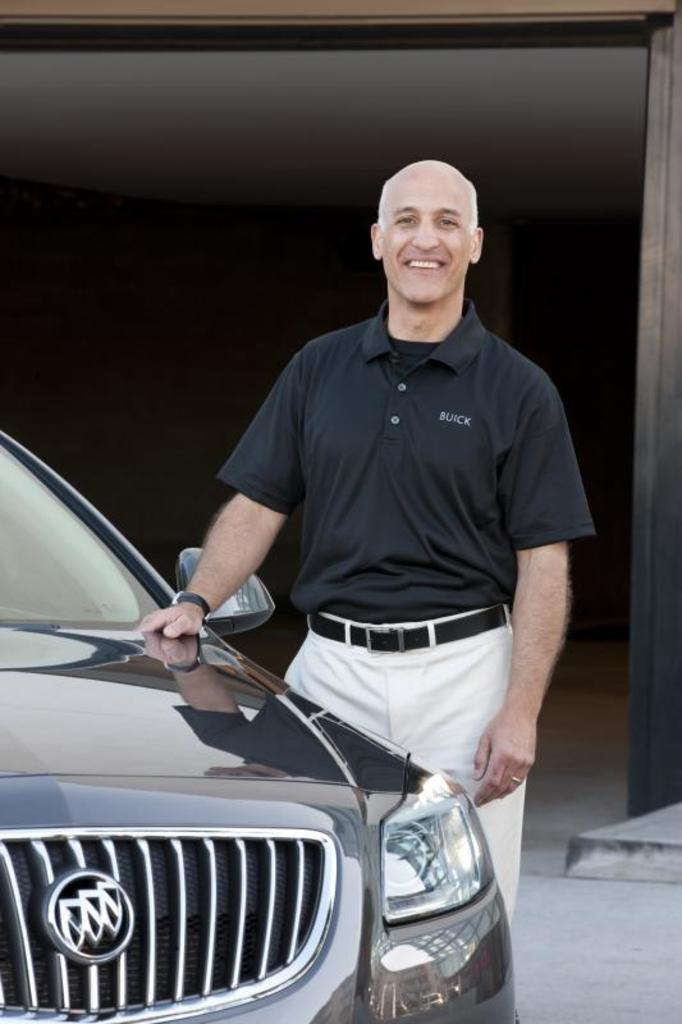What is the main subject of the image? There is a man standing in the middle of the image. What is the man wearing in the image? The man is wearing a black t-shirt. What can be seen on the left side of the image? There is a car on the left side of the image. How would you describe the overall lighting in the image? The background of the image is dark. What type of jewel is the man holding in the image? There is no jewel present in the image; the man is wearing a black t-shirt and standing in the middle of the image. Can you see a bee buzzing around the man in the image? There is no bee present in the image; the focus is on the man and the car in the background. 